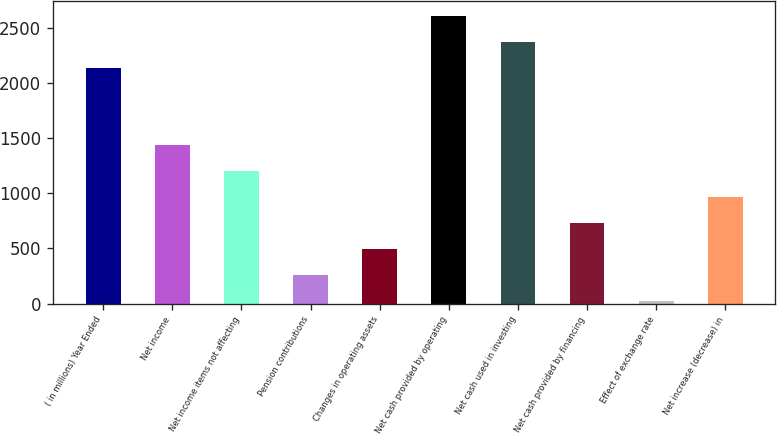Convert chart. <chart><loc_0><loc_0><loc_500><loc_500><bar_chart><fcel>( in millions) Year Ended<fcel>Net income<fcel>Net income items not affecting<fcel>Pension contributions<fcel>Changes in operating assets<fcel>Net cash provided by operating<fcel>Net cash used in investing<fcel>Net cash provided by financing<fcel>Effect of exchange rate<fcel>Net increase (decrease) in<nl><fcel>2140.21<fcel>1433.74<fcel>1198.25<fcel>256.29<fcel>491.78<fcel>2611.19<fcel>2375.7<fcel>727.27<fcel>20.8<fcel>962.76<nl></chart> 